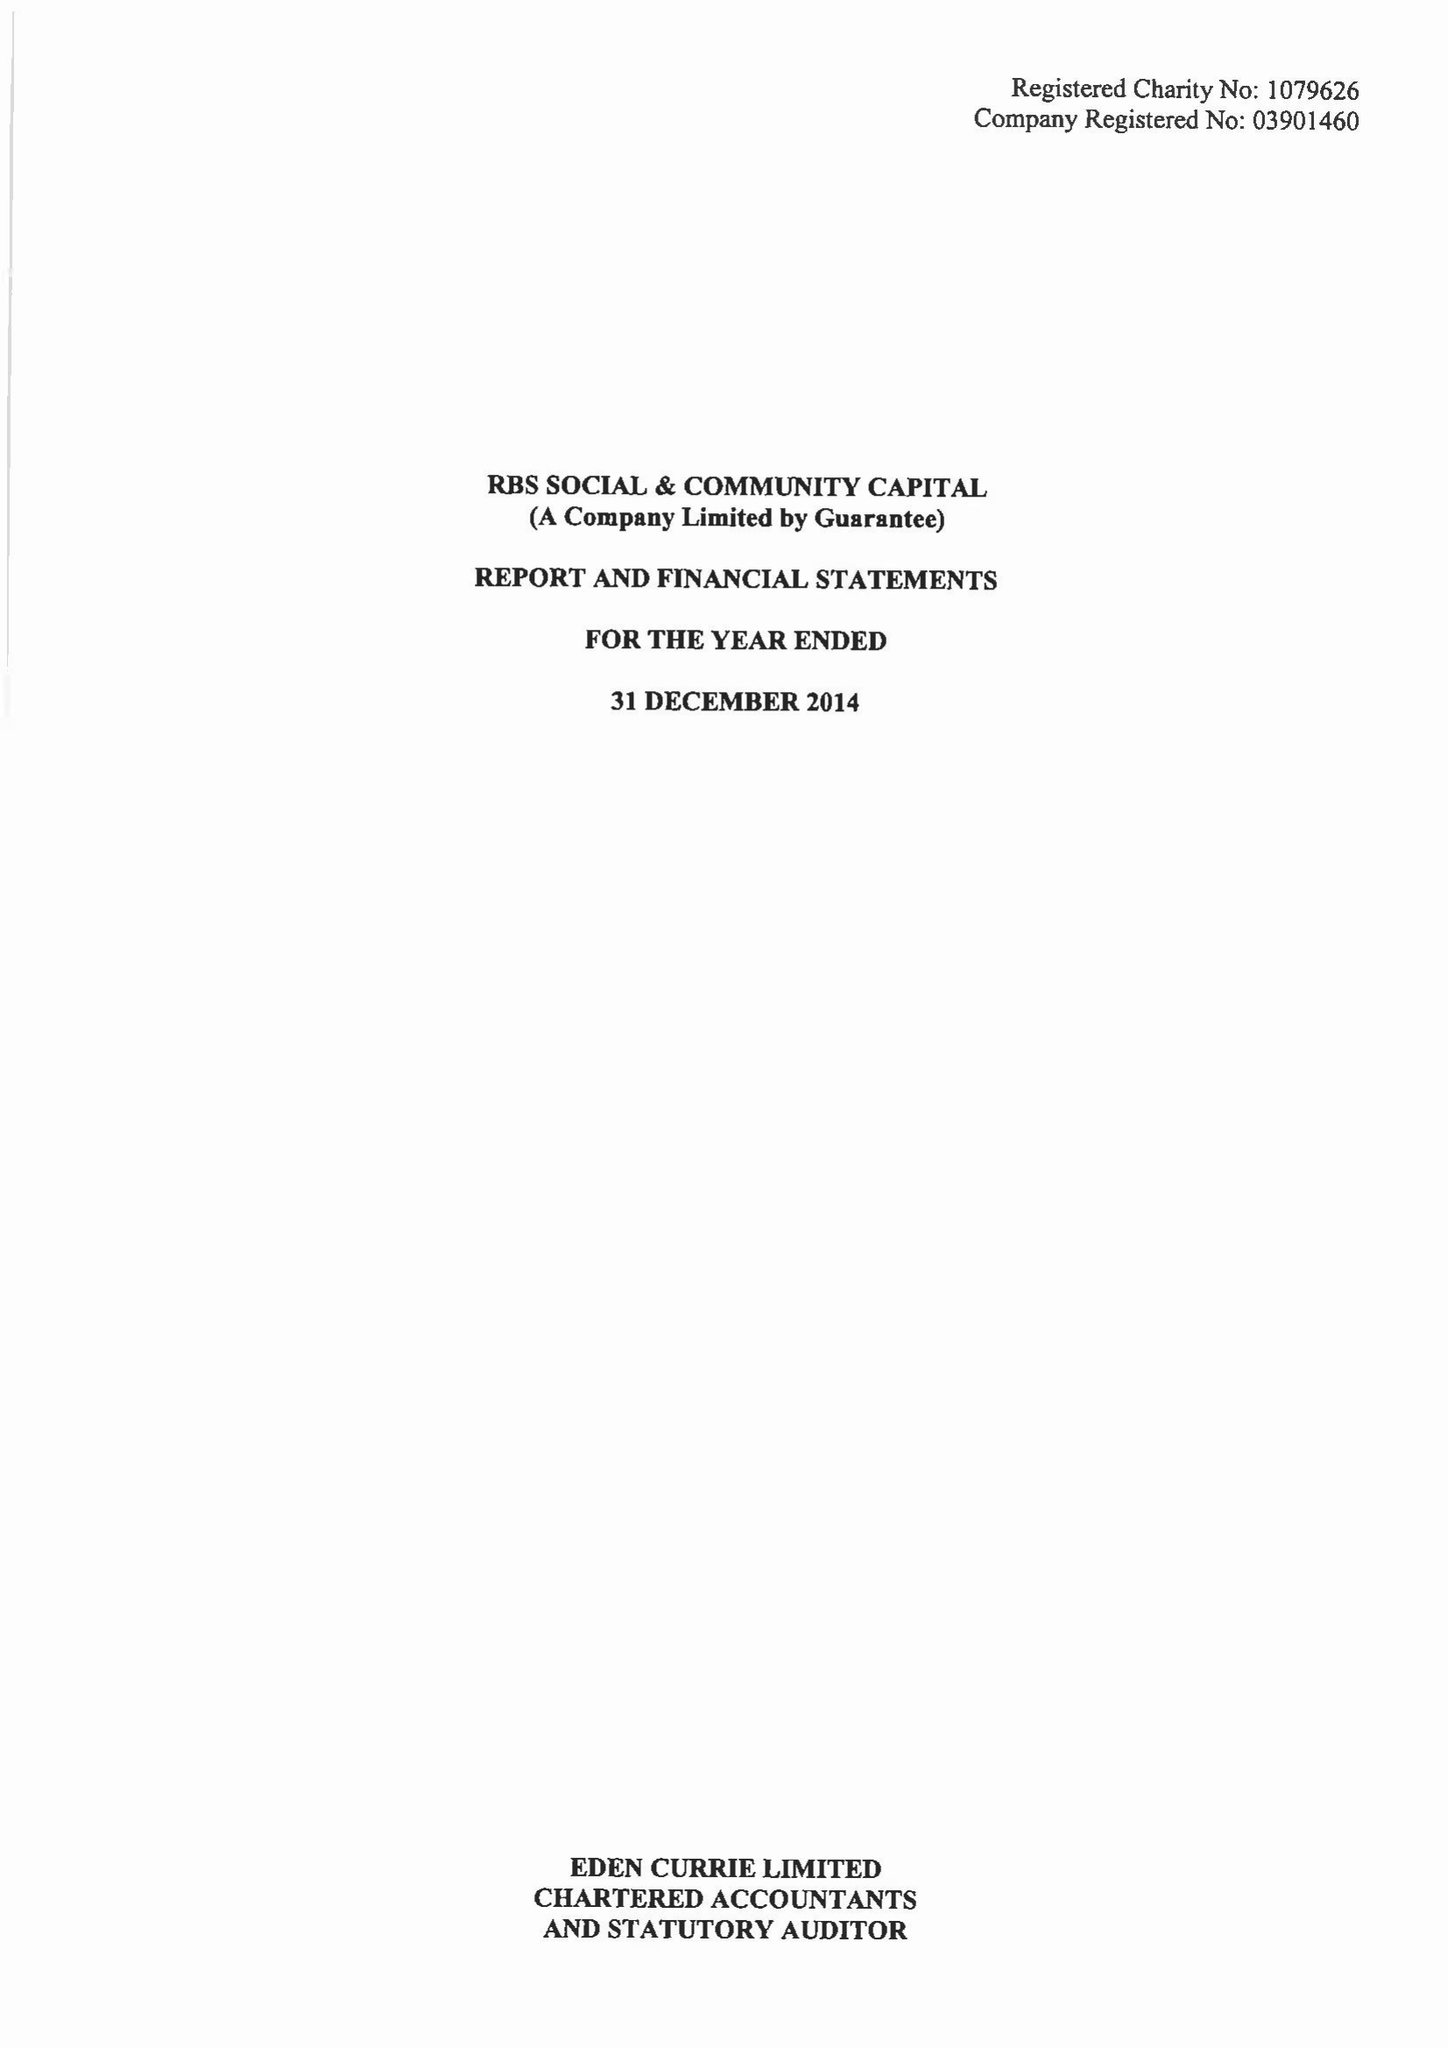What is the value for the address__postcode?
Answer the question using a single word or phrase. EC2M 4AA 